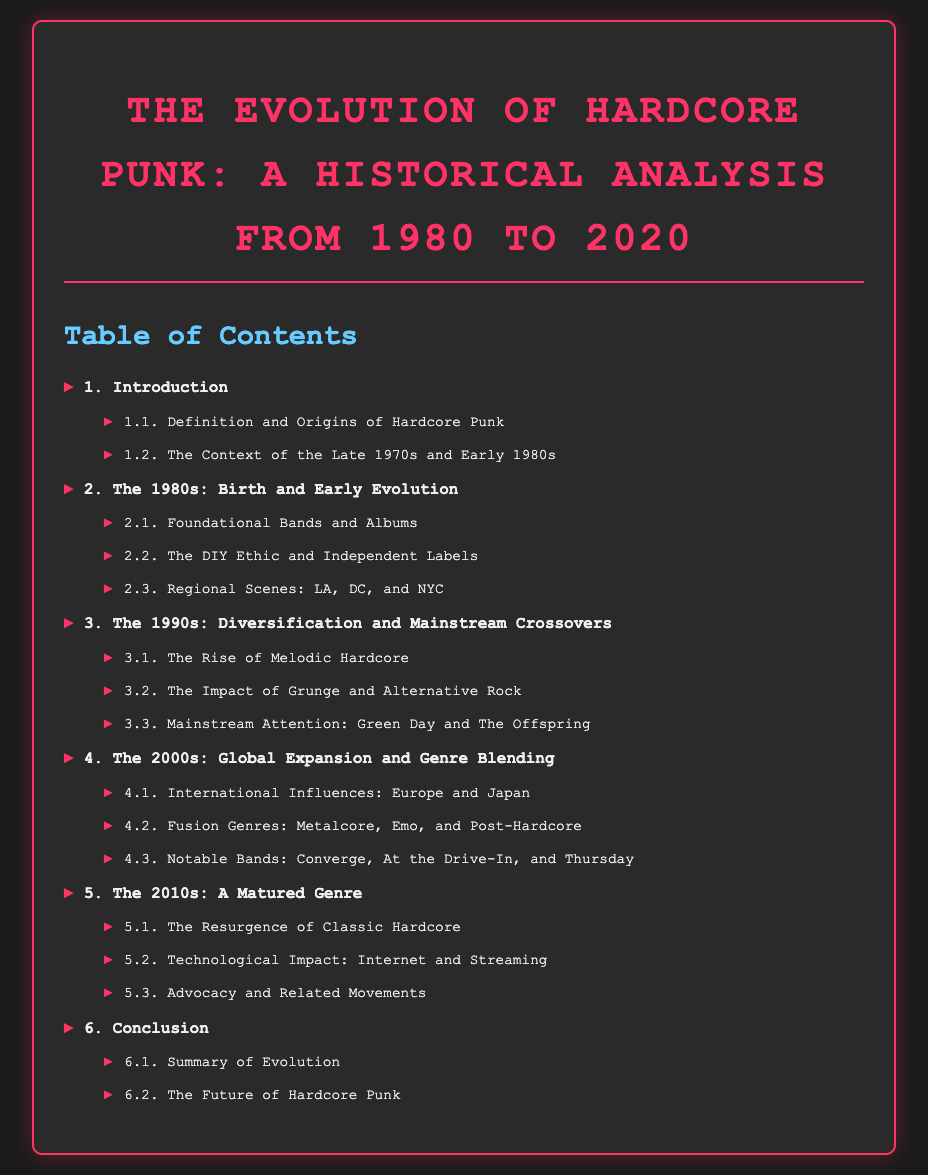What is the title of the document? The title is specified at the top of the document and serves as the main heading.
Answer: The Evolution of Hardcore Punk: A Historical Analysis from 1980 to 2020 How many chapters are there in the document? The chapters are listed in a numbered format under the Table of Contents.
Answer: 6 What year marks the starting point of the historical analysis? The introductory section highlights the initial year of focus for the historical analysis of hardcore punk.
Answer: 1980 Which subgenre is discussed as a rise in the 1990s? A section specifically addresses this emerging style during the 1990s in the Table of Contents.
Answer: Melodic Hardcore Name one notable band mentioned from the 2000s. The document lists notable bands as part of the discussion on global expansion and genre blending in the 2000s.
Answer: Converge What is the final section of the document? The last section in the Table of Contents outlines the concluding thoughts and reflections.
Answer: The Future of Hardcore Punk 